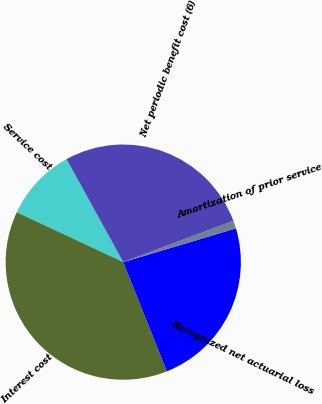Convert chart to OTSL. <chart><loc_0><loc_0><loc_500><loc_500><pie_chart><fcel>Service cost<fcel>Interest cost<fcel>Recognized net actuarial loss<fcel>Amortization of prior service<fcel>Net periodic benefit cost (6)<nl><fcel>10.02%<fcel>38.02%<fcel>23.59%<fcel>1.09%<fcel>27.29%<nl></chart> 